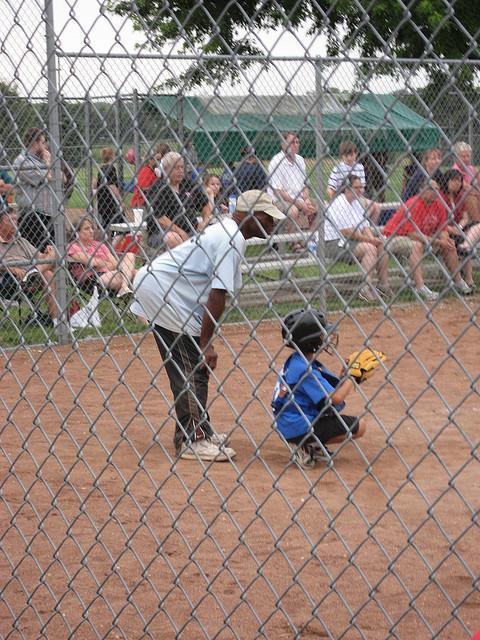How many people are standing on the dirt?
Give a very brief answer. 2. How many men are wearing hats?
Give a very brief answer. 1. How many people are in the photo?
Give a very brief answer. 8. 